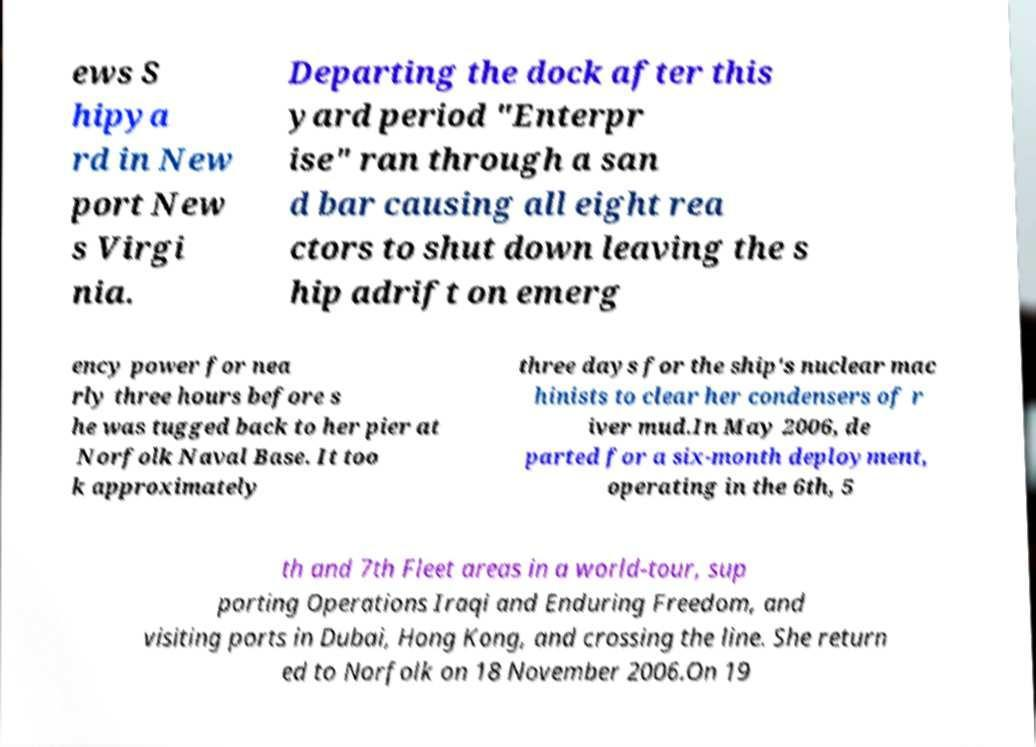Please identify and transcribe the text found in this image. ews S hipya rd in New port New s Virgi nia. Departing the dock after this yard period "Enterpr ise" ran through a san d bar causing all eight rea ctors to shut down leaving the s hip adrift on emerg ency power for nea rly three hours before s he was tugged back to her pier at Norfolk Naval Base. It too k approximately three days for the ship's nuclear mac hinists to clear her condensers of r iver mud.In May 2006, de parted for a six-month deployment, operating in the 6th, 5 th and 7th Fleet areas in a world-tour, sup porting Operations Iraqi and Enduring Freedom, and visiting ports in Dubai, Hong Kong, and crossing the line. She return ed to Norfolk on 18 November 2006.On 19 